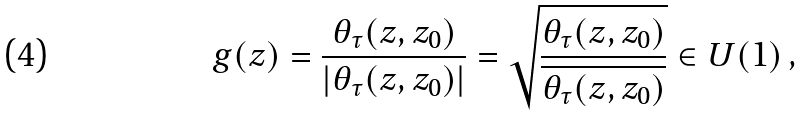<formula> <loc_0><loc_0><loc_500><loc_500>g ( z ) = \frac { \theta _ { \tau } ( z , z _ { 0 } ) } { | \theta _ { \tau } ( z , z _ { 0 } ) | } = \sqrt { \frac { \theta _ { \tau } ( z , z _ { 0 } ) } { \overline { { { \theta _ { \tau } ( z , z _ { 0 } ) } } } } } \in U ( 1 ) \, ,</formula> 